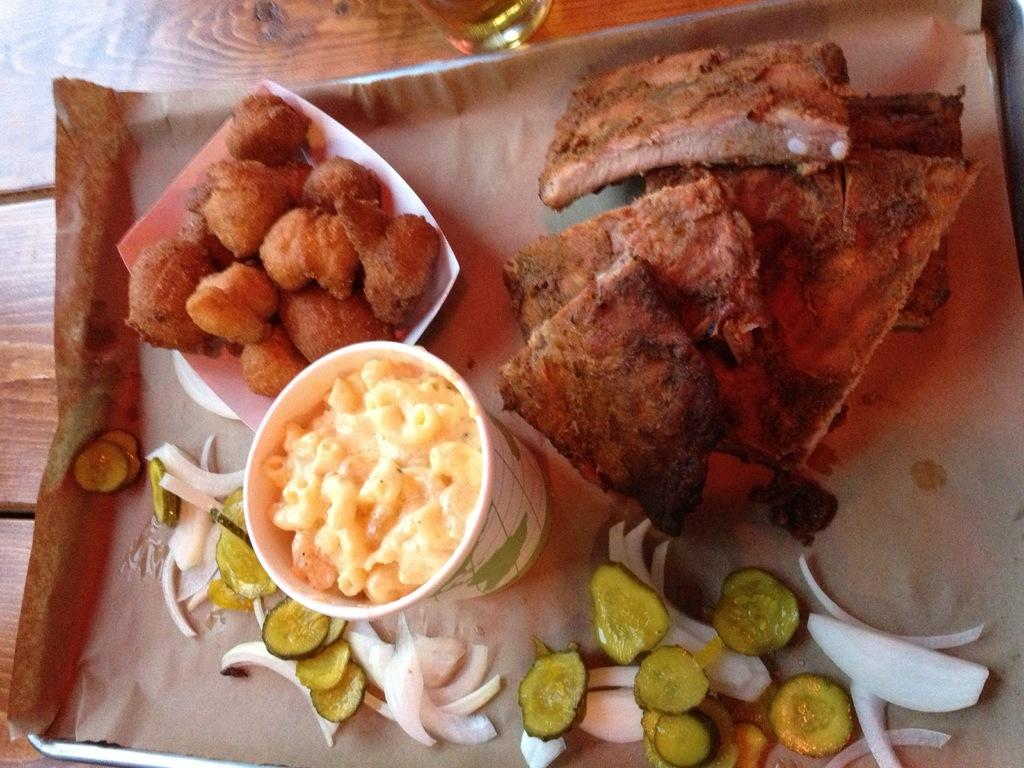What object is present on the table in the image? There is a plate on the table in the image. What is the purpose of the plate in the image? The plate is used to hold food. What type of food can be seen on the plate? The facts do not specify the type of food on the plate. How does the brother transport the underwear in the image? There is no brother or underwear present in the image. 